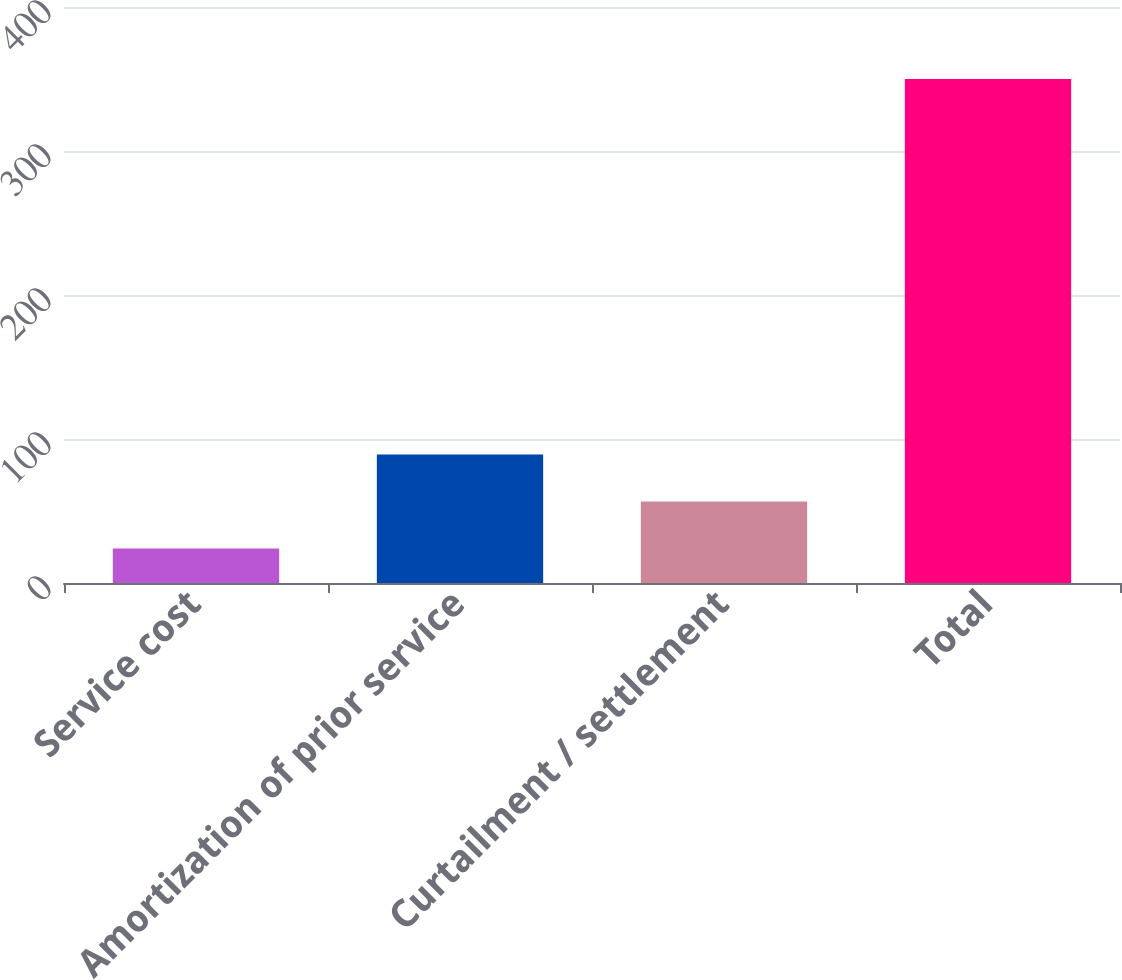Convert chart. <chart><loc_0><loc_0><loc_500><loc_500><bar_chart><fcel>Service cost<fcel>Amortization of prior service<fcel>Curtailment / settlement<fcel>Total<nl><fcel>24<fcel>89.2<fcel>56.6<fcel>350<nl></chart> 